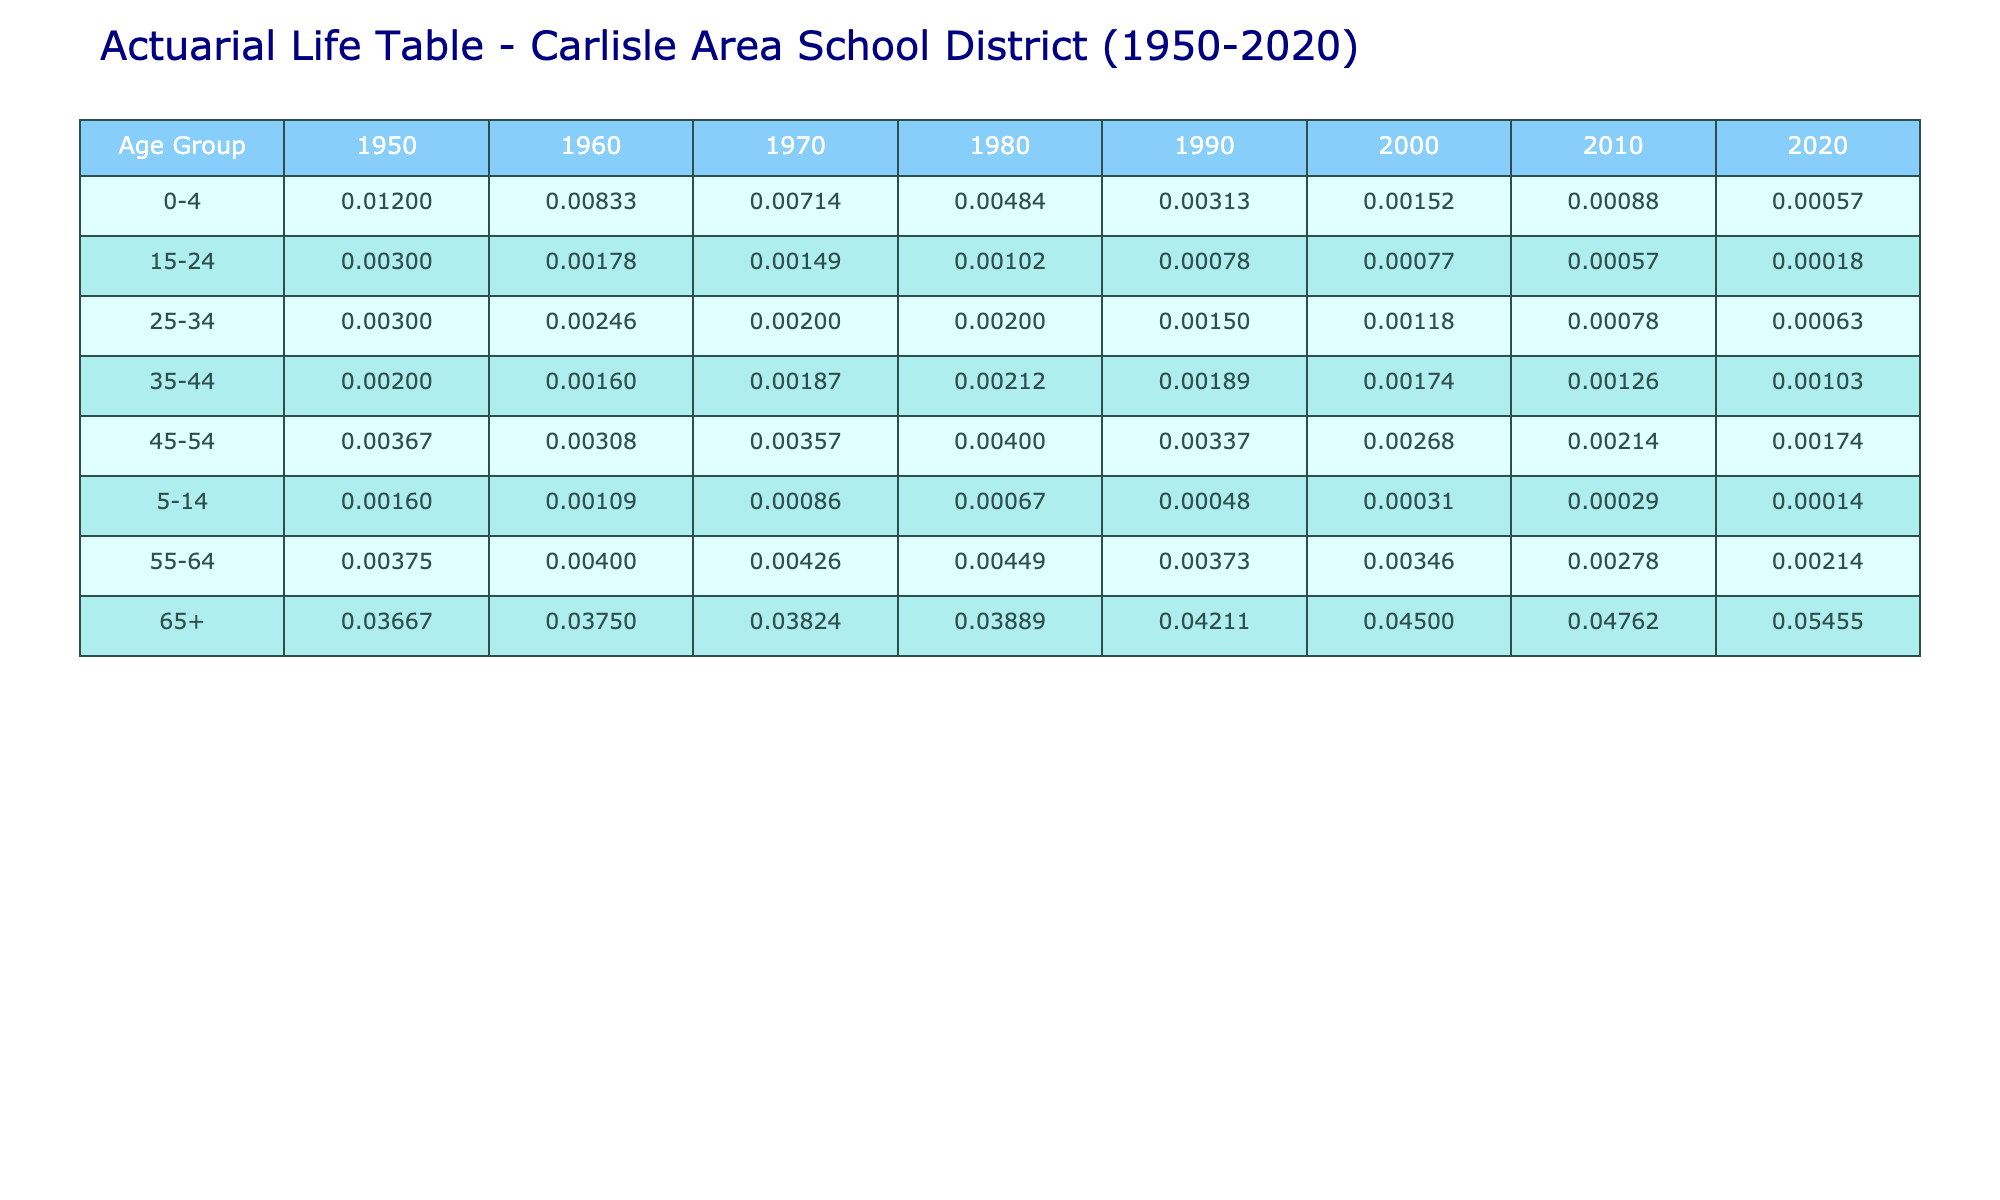What was the mortality rate for the age group 0-4 in 2010? In the table, looking under the age group 0-4 and the year 2010, the mortality rate listed is 0.00088.
Answer: 0.00088 How many deaths occurred in the age group 65+ in 2000? In the table, for the age group 65+ and in the year 2000, the number of deaths recorded is 90.
Answer: 90 Is the mortality rate for the age group 5-14 lower in 2020 than in 1980? Comparing the rates, the mortality rate for age group 5-14 in 2020 is 0.00014, and in 1980 it is 0.00067. Since 0.00014 is less than 0.00067, the mortality rate in 2020 is indeed lower.
Answer: Yes What is the trend in mortality rates for the age group 25-34 from 1950 to 2020? By examining the table, the mortality rates for this age group have shown a decline from 0.003 in 1950 to 0.00063 in 2020. This signifies a downward trend over the years.
Answer: Declining What was the total number of deaths in the age group 45-54 from 1950 to 2020? Summing the deaths across the years for the age group 45-54: 22 (1950) + 20 (1960) + 25 (1970) + 30 (1980) + 27 (1990) + 22 (2000) + 18 (2010) + 15 (2020) equals 169.
Answer: 169 What is the average mortality rate for the age group 55-64 across all years? The mortality rates for age group 55-64 are: 0.00375 (1950), 0.004 (1960), 0.00426 (1970), 0.00449 (1980), 0.00373 (1990), 0.00346 (2000), 0.00278 (2010), and 0.00214 (2020). Summing these values equals 0.02861, and dividing by 8 (the number of years) yields an average of approximately 0.00357625, which rounds to 0.00358.
Answer: 0.00358 Did the mortality rate for age group 35-44 increase from 1990 to 2020? The mortality rate for age group 35-44 in 1990 is 0.00189, while in 2020 it is 0.00103. Since 0.00103 is less than 0.00189, the rate did not increase but instead decreased.
Answer: No What was the maximum mortality rate observed in the age group 65+ and in which year did it occur? The table shows that the highest mortality rate for the age group 65+ is 0.05455 in the year 2020.
Answer: 0.05455 in 2020 